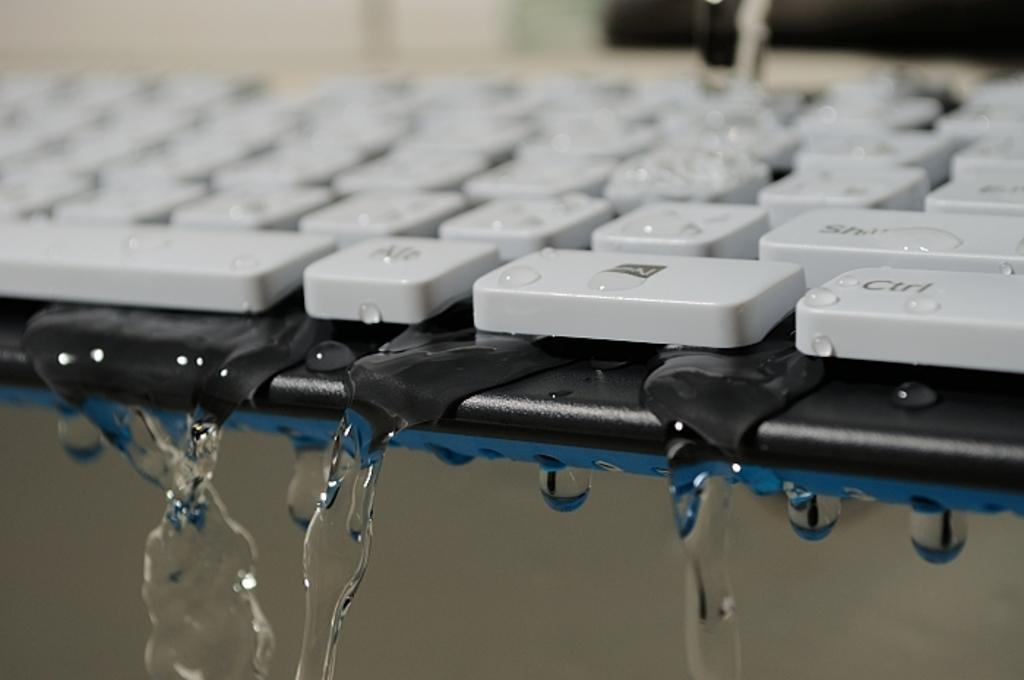<image>
Write a terse but informative summary of the picture. Water drips from the Ctrl and Alt keys on a keyboard, among others. 